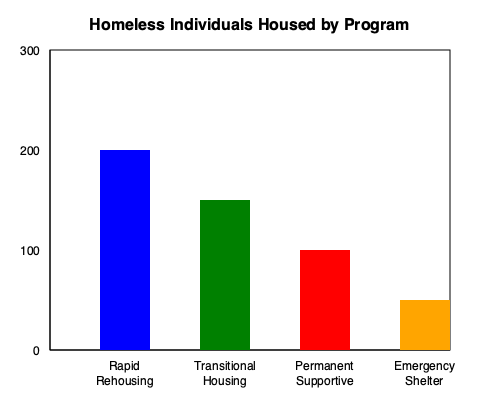Based on the bar graph showing the number of homeless individuals housed through various programs, which program has been most effective in housing the largest number of individuals, and approximately how many people were housed through this program? To answer this question, we need to analyze the bar graph and follow these steps:

1. Identify the programs represented in the graph:
   - Rapid Rehousing
   - Transitional Housing
   - Permanent Supportive
   - Emergency Shelter

2. Compare the heights of the bars:
   - Rapid Rehousing: Tallest bar
   - Transitional Housing: Second tallest
   - Permanent Supportive: Third tallest
   - Emergency Shelter: Shortest bar

3. Determine the most effective program:
   The tallest bar represents the program that housed the most individuals, which is Rapid Rehousing.

4. Estimate the number of people housed:
   - The y-axis shows intervals of 100, with the top of the scale at 300.
   - The Rapid Rehousing bar extends to about 2/3 of the way between 200 and 300.
   - We can estimate this to be approximately 200 + (2/3 * 100) ≈ 267 individuals.

Therefore, the Rapid Rehousing program has been most effective, housing approximately 267 individuals.
Answer: Rapid Rehousing, approximately 267 individuals 